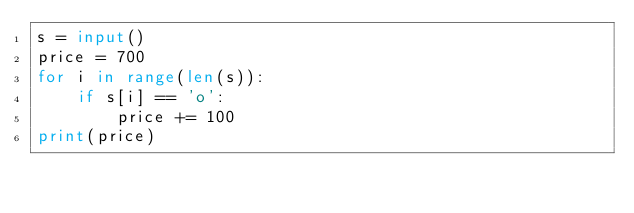Convert code to text. <code><loc_0><loc_0><loc_500><loc_500><_Python_>s = input()
price = 700
for i in range(len(s)):
    if s[i] == 'o':
        price += 100
print(price)</code> 